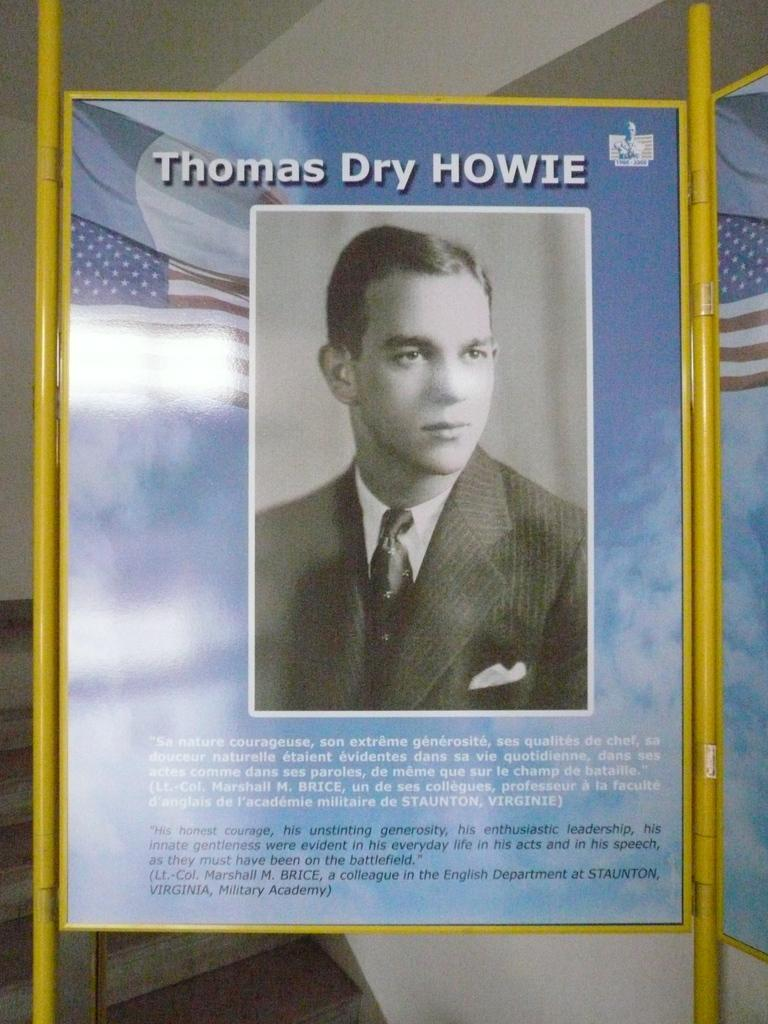Provide a one-sentence caption for the provided image. A picture of thomas dry howie and white and black words under his picture. 